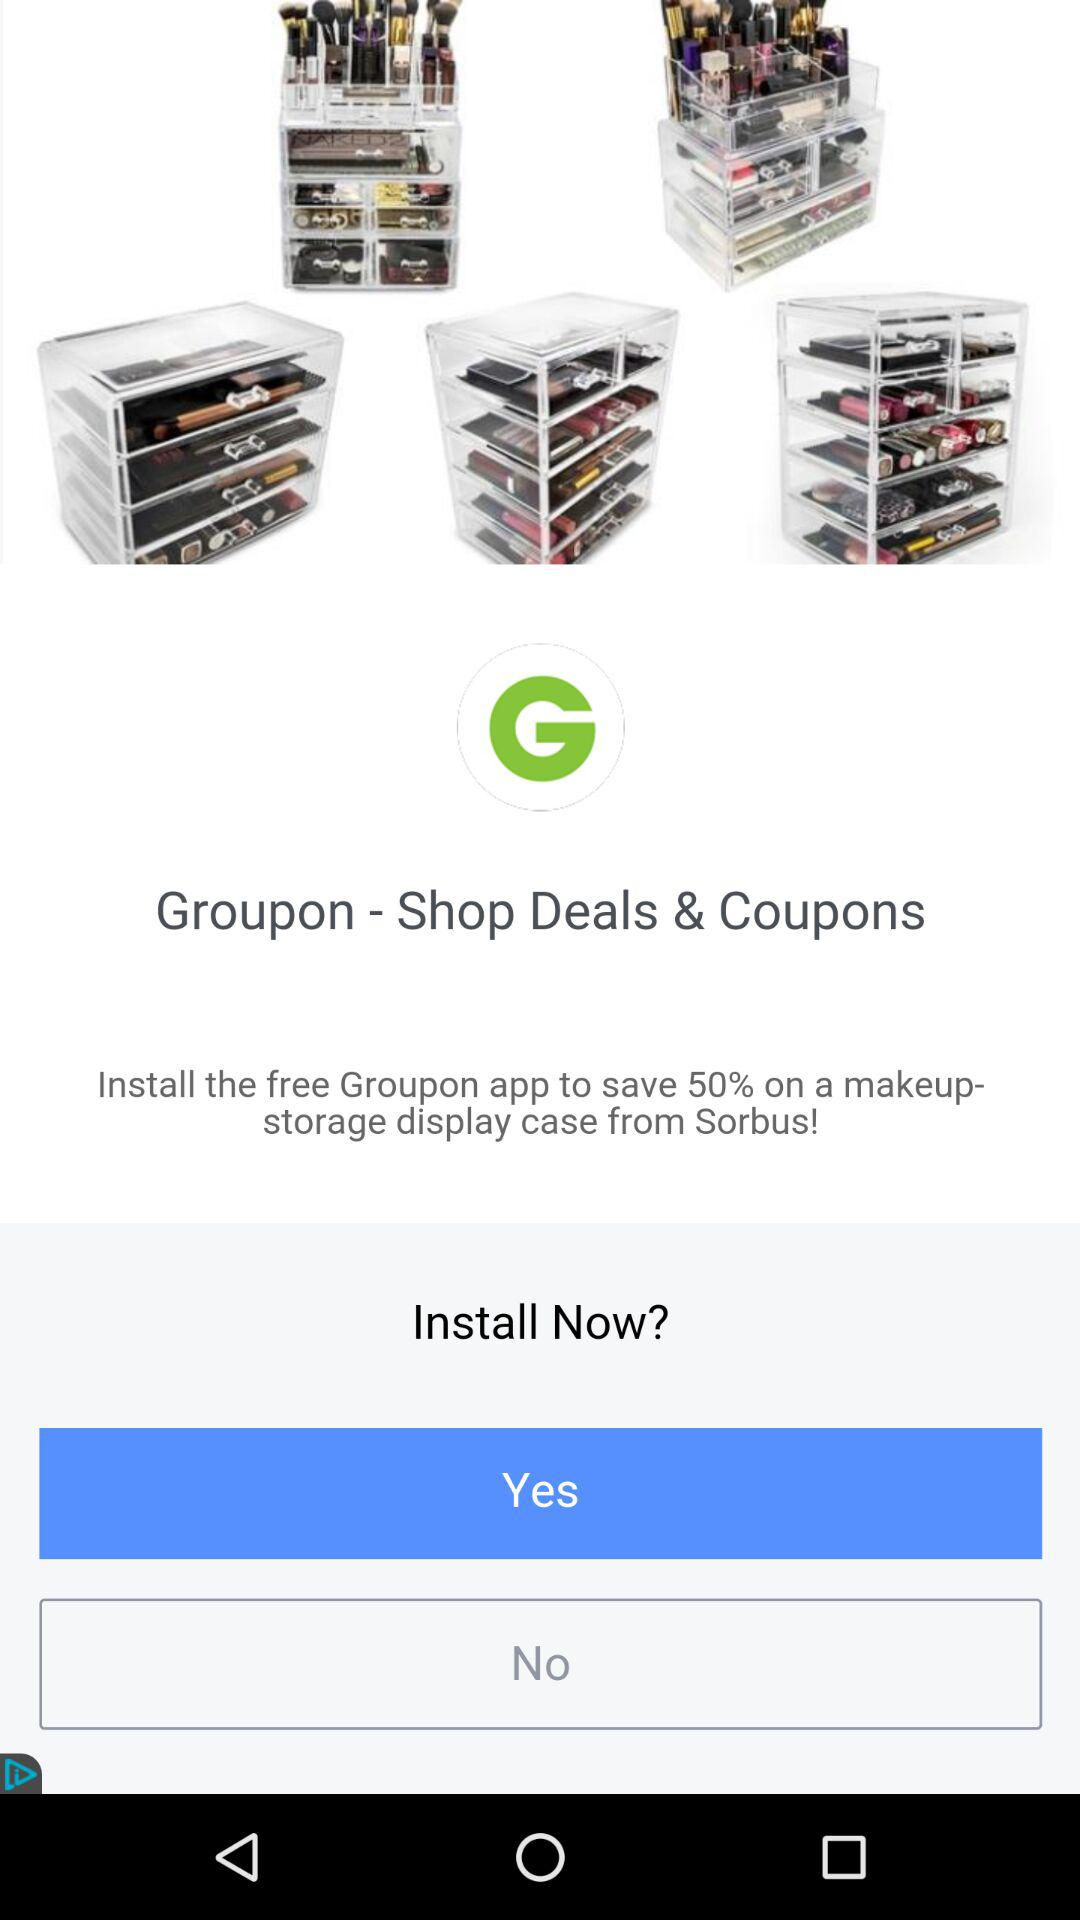How many acrylic makeup organizers are shown?
Answer the question using a single word or phrase. 5 